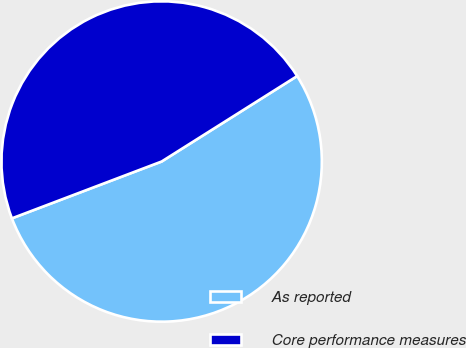Convert chart. <chart><loc_0><loc_0><loc_500><loc_500><pie_chart><fcel>As reported<fcel>Core performance measures<nl><fcel>53.18%<fcel>46.82%<nl></chart> 